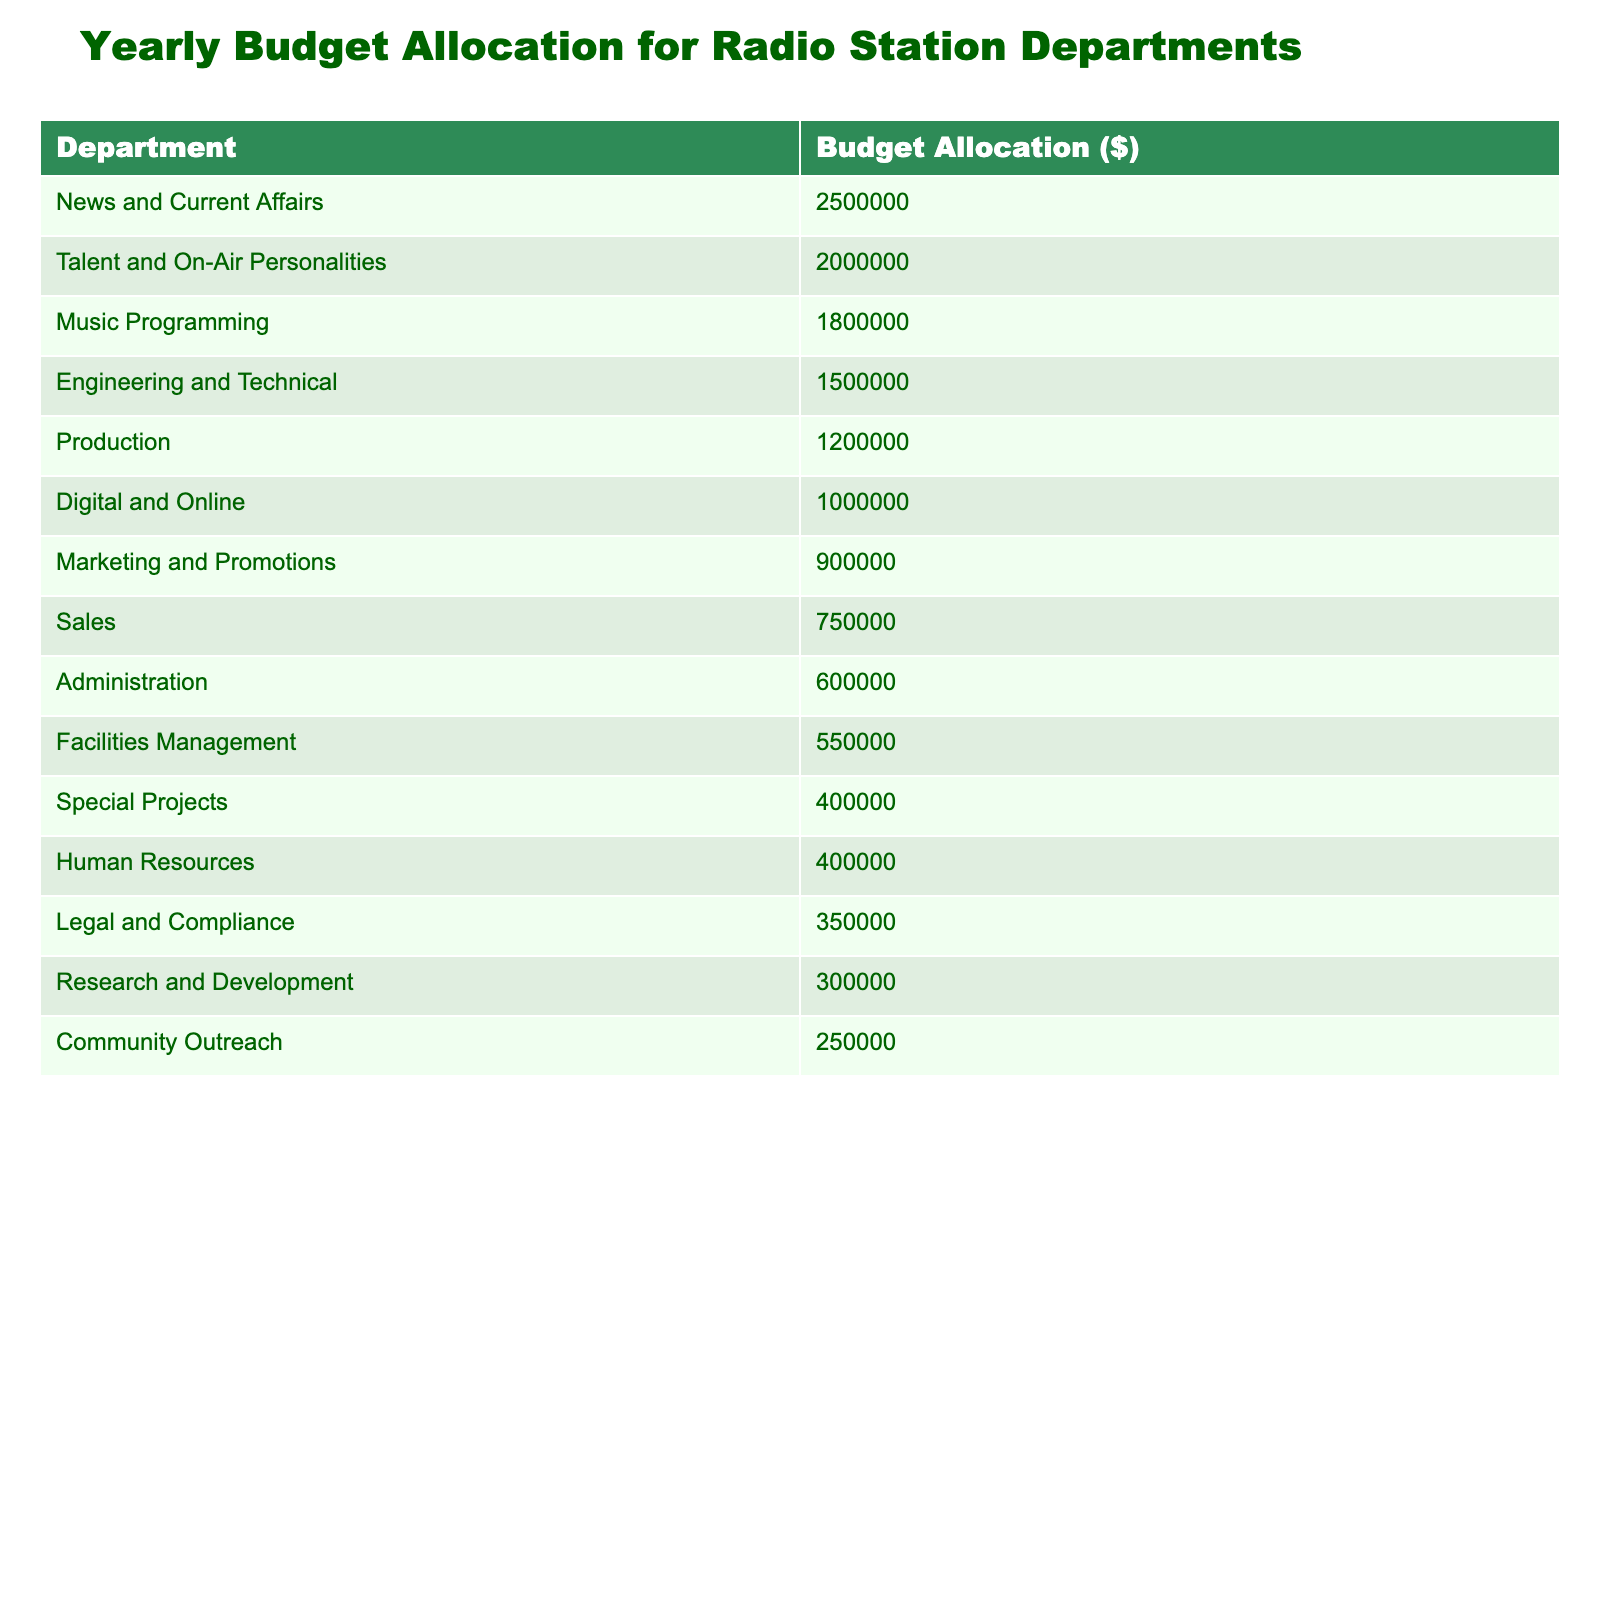What is the budget allocation for Music Programming? The table lists Music Programming with a budget allocation of $1,800,000, which can be found directly under the corresponding department.
Answer: 1,800,000 Which department has the highest budget allocation? By examining the values in the table, News and Current Affairs has the highest budget allocation of $2,500,000.
Answer: 2,500,000 How much more does the News and Current Affairs department receive than the Marketing and Promotions department? The News and Current Affairs budget is $2,500,000 while Marketing and Promotions is $900,000. The difference is calculated as $2,500,000 - $900,000 = $1,600,000.
Answer: 1,600,000 What is the total budget allocation for Digital and Online and Special Projects combined? To find the combined total, add the budgets of Digital and Online ($1,000,000) and Special Projects ($400,000): $1,000,000 + $400,000 = $1,400,000.
Answer: 1,400,000 Is the budget allocation for Facilities Management greater than that for Human Resources? Facilities Management has a budget of $550,000, while Human Resources has $400,000. Since $550,000 is greater than $400,000, the statement is true.
Answer: Yes What is the average budget allocation for all departments? First, sum all budget allocations: $2,500,000 + $1,800,000 + $1,200,000 + $1,500,000 + $900,000 + $750,000 + $600,000 + $1,000,000 + $400,000 + $2,000,000 + $300,000 + $250,000 + $350,000 + $400,000 + $550,000 = $15,850,000. There are 15 departments, so the average is $15,850,000 / 15 = $1,056,667.
Answer: 1,056,667 Which department's budget allocation is the same as Research and Development? Research and Development has a budget allocation of $300,000, which is the same as the budget for Community Outreach, as both are listed at that amount.
Answer: Community Outreach How does the total budget allocation for talent-related departments (Talent and On-Air Personalities and Production) compare to the total for technical departments (Engineering and Technical, Facilities Management)? The budget for Talent and On-Air Personalities is $2,000,000 and Production is $1,200,000, totaling $3,200,000. The technical departments’ budgets are Engineering and Technical ($1,500,000) and Facilities Management ($550,000), totaling $2,050,000. Comparing the two totals: $3,200,000 > $2,050,000, which shows talent-related departments receive more.
Answer: Talent-related departments receive more Count how many departments have a budget allocation of less than $1,000,000. By checking each department, Marketing and Promotions ($900,000), Sales ($750,000), Administration ($600,000), Special Projects ($400,000), Community Outreach ($250,000), and Human Resources ($400,000) total 6 departments with budgets less than $1,000,000.
Answer: 6 